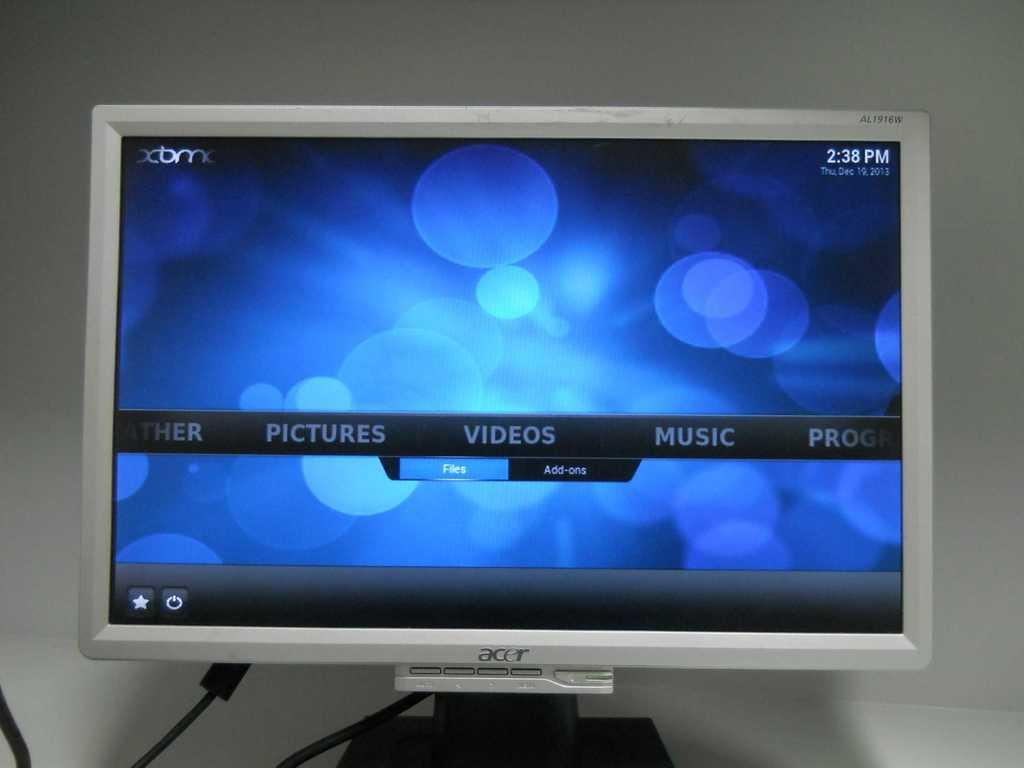<image>
Provide a brief description of the given image. An Acer monitor with a scrolling media menu reading "Pictures", "Videos", "Music", and "Programs". 